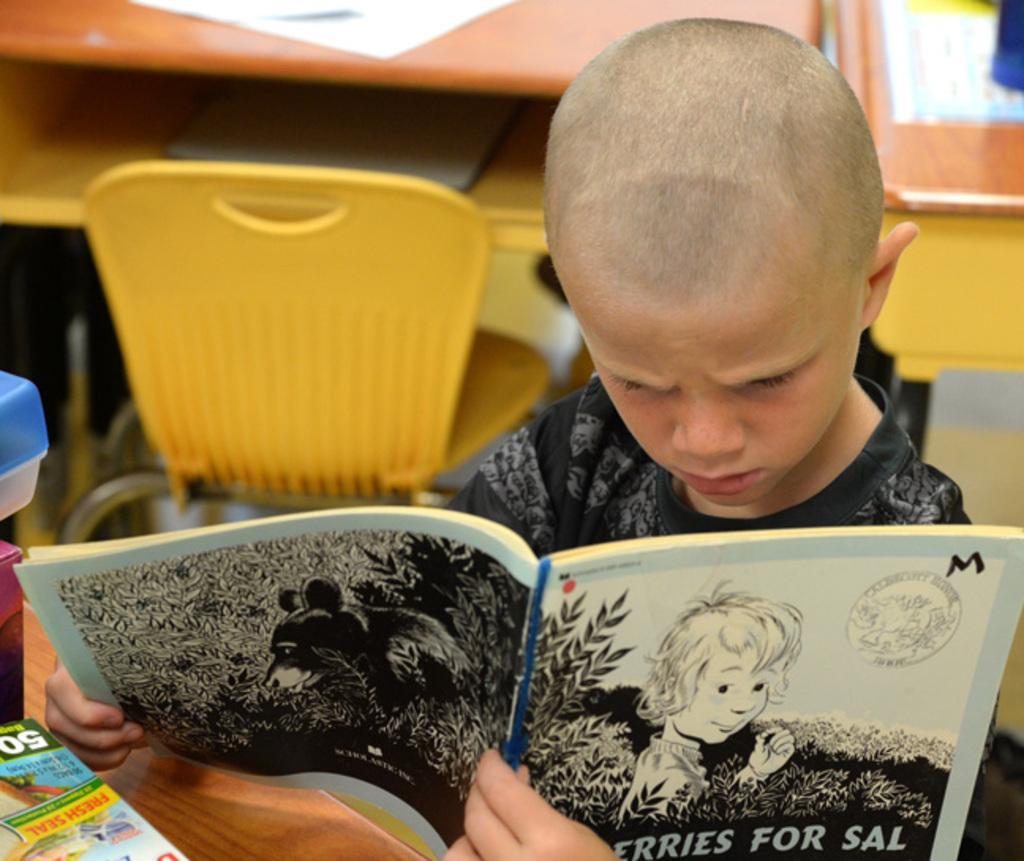Please provide a concise description of this image. In this image in the foreground there is one boy who is holding a book and reading. At the bottom there is a table, on the table there are some books and some objects. In the background there are some chairs, and tables. On the tables there are some papers, and some board and some other objects. 